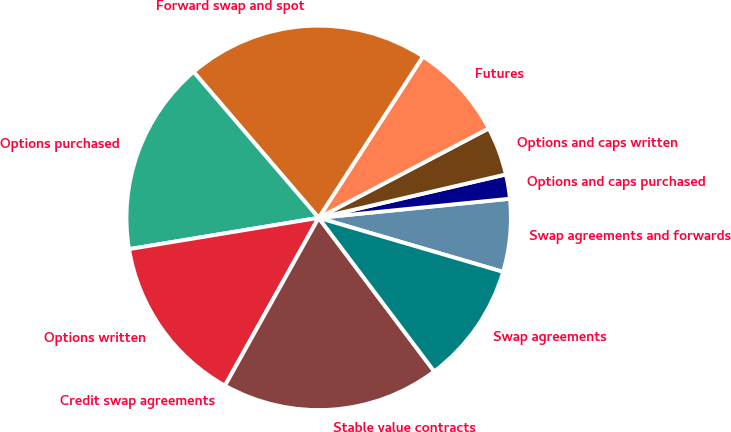Convert chart. <chart><loc_0><loc_0><loc_500><loc_500><pie_chart><fcel>Swap agreements and forwards<fcel>Options and caps purchased<fcel>Options and caps written<fcel>Futures<fcel>Forward swap and spot<fcel>Options purchased<fcel>Options written<fcel>Credit swap agreements<fcel>Stable value contracts<fcel>Swap agreements<nl><fcel>6.12%<fcel>2.04%<fcel>4.08%<fcel>8.16%<fcel>20.41%<fcel>16.33%<fcel>14.29%<fcel>0.0%<fcel>18.37%<fcel>10.2%<nl></chart> 